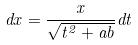<formula> <loc_0><loc_0><loc_500><loc_500>d x = \frac { x } { \sqrt { t ^ { 2 } + a b } } d t</formula> 